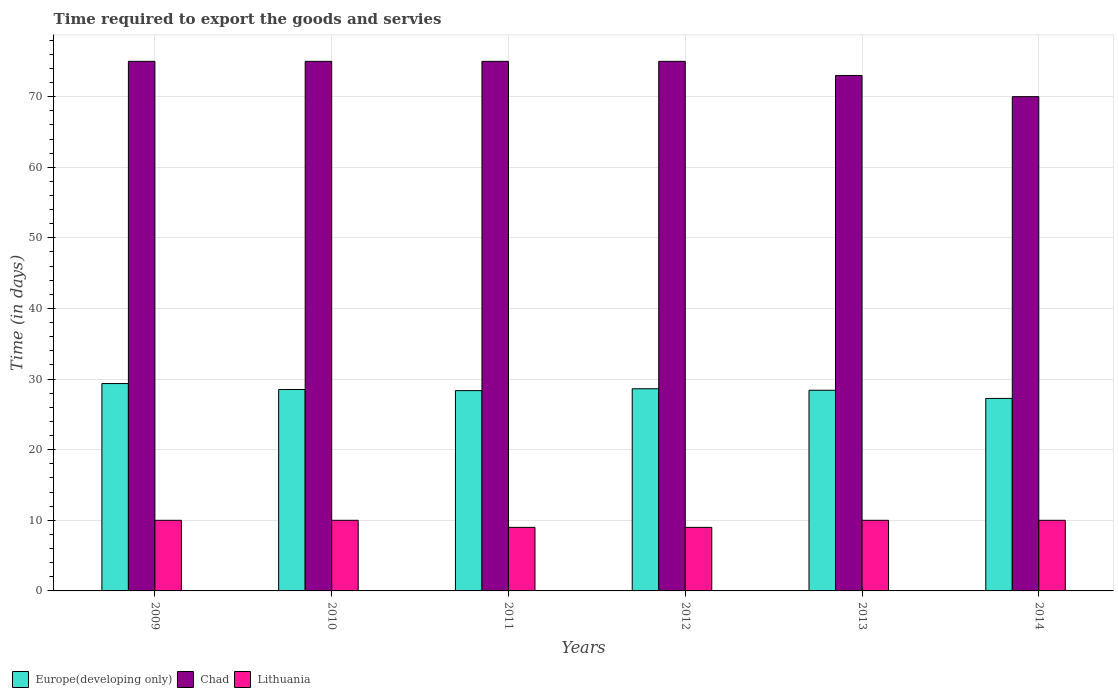How many different coloured bars are there?
Offer a terse response. 3. Are the number of bars per tick equal to the number of legend labels?
Make the answer very short. Yes. How many bars are there on the 6th tick from the left?
Provide a succinct answer. 3. How many bars are there on the 1st tick from the right?
Your answer should be very brief. 3. What is the number of days required to export the goods and services in Europe(developing only) in 2010?
Offer a terse response. 28.53. Across all years, what is the maximum number of days required to export the goods and services in Chad?
Your answer should be very brief. 75. Across all years, what is the minimum number of days required to export the goods and services in Europe(developing only)?
Provide a succinct answer. 27.26. In which year was the number of days required to export the goods and services in Chad minimum?
Make the answer very short. 2014. What is the total number of days required to export the goods and services in Chad in the graph?
Ensure brevity in your answer.  443. What is the difference between the number of days required to export the goods and services in Europe(developing only) in 2011 and that in 2014?
Provide a short and direct response. 1.11. What is the difference between the number of days required to export the goods and services in Chad in 2011 and the number of days required to export the goods and services in Europe(developing only) in 2013?
Provide a short and direct response. 46.58. What is the average number of days required to export the goods and services in Europe(developing only) per year?
Keep it short and to the point. 28.43. In the year 2014, what is the difference between the number of days required to export the goods and services in Europe(developing only) and number of days required to export the goods and services in Chad?
Your answer should be compact. -42.74. What is the ratio of the number of days required to export the goods and services in Chad in 2012 to that in 2014?
Make the answer very short. 1.07. Is the number of days required to export the goods and services in Europe(developing only) in 2010 less than that in 2012?
Keep it short and to the point. Yes. Is the difference between the number of days required to export the goods and services in Europe(developing only) in 2010 and 2011 greater than the difference between the number of days required to export the goods and services in Chad in 2010 and 2011?
Keep it short and to the point. Yes. What is the difference between the highest and the second highest number of days required to export the goods and services in Europe(developing only)?
Provide a short and direct response. 0.74. What is the difference between the highest and the lowest number of days required to export the goods and services in Lithuania?
Ensure brevity in your answer.  1. Is the sum of the number of days required to export the goods and services in Chad in 2009 and 2013 greater than the maximum number of days required to export the goods and services in Lithuania across all years?
Offer a terse response. Yes. What does the 3rd bar from the left in 2009 represents?
Make the answer very short. Lithuania. What does the 1st bar from the right in 2010 represents?
Offer a terse response. Lithuania. What is the difference between two consecutive major ticks on the Y-axis?
Keep it short and to the point. 10. Does the graph contain any zero values?
Your response must be concise. No. How many legend labels are there?
Ensure brevity in your answer.  3. What is the title of the graph?
Offer a very short reply. Time required to export the goods and servies. Does "Central Europe" appear as one of the legend labels in the graph?
Offer a terse response. No. What is the label or title of the X-axis?
Provide a succinct answer. Years. What is the label or title of the Y-axis?
Your response must be concise. Time (in days). What is the Time (in days) of Europe(developing only) in 2009?
Give a very brief answer. 29.37. What is the Time (in days) of Europe(developing only) in 2010?
Offer a terse response. 28.53. What is the Time (in days) of Chad in 2010?
Offer a terse response. 75. What is the Time (in days) in Lithuania in 2010?
Give a very brief answer. 10. What is the Time (in days) of Europe(developing only) in 2011?
Provide a short and direct response. 28.37. What is the Time (in days) of Europe(developing only) in 2012?
Ensure brevity in your answer.  28.63. What is the Time (in days) of Europe(developing only) in 2013?
Your answer should be very brief. 28.42. What is the Time (in days) in Chad in 2013?
Your answer should be very brief. 73. What is the Time (in days) in Europe(developing only) in 2014?
Offer a very short reply. 27.26. Across all years, what is the maximum Time (in days) of Europe(developing only)?
Your answer should be compact. 29.37. Across all years, what is the maximum Time (in days) of Chad?
Make the answer very short. 75. Across all years, what is the minimum Time (in days) in Europe(developing only)?
Offer a very short reply. 27.26. Across all years, what is the minimum Time (in days) in Lithuania?
Give a very brief answer. 9. What is the total Time (in days) of Europe(developing only) in the graph?
Your answer should be compact. 170.58. What is the total Time (in days) in Chad in the graph?
Make the answer very short. 443. What is the total Time (in days) of Lithuania in the graph?
Offer a very short reply. 58. What is the difference between the Time (in days) of Europe(developing only) in 2009 and that in 2010?
Offer a terse response. 0.84. What is the difference between the Time (in days) in Europe(developing only) in 2009 and that in 2011?
Make the answer very short. 1. What is the difference between the Time (in days) of Lithuania in 2009 and that in 2011?
Your answer should be very brief. 1. What is the difference between the Time (in days) of Europe(developing only) in 2009 and that in 2012?
Your answer should be compact. 0.74. What is the difference between the Time (in days) of Chad in 2009 and that in 2013?
Offer a terse response. 2. What is the difference between the Time (in days) of Lithuania in 2009 and that in 2013?
Your response must be concise. 0. What is the difference between the Time (in days) of Europe(developing only) in 2009 and that in 2014?
Ensure brevity in your answer.  2.11. What is the difference between the Time (in days) in Chad in 2009 and that in 2014?
Provide a succinct answer. 5. What is the difference between the Time (in days) in Europe(developing only) in 2010 and that in 2011?
Offer a very short reply. 0.16. What is the difference between the Time (in days) of Chad in 2010 and that in 2011?
Offer a very short reply. 0. What is the difference between the Time (in days) in Europe(developing only) in 2010 and that in 2012?
Offer a terse response. -0.11. What is the difference between the Time (in days) of Europe(developing only) in 2010 and that in 2013?
Offer a terse response. 0.11. What is the difference between the Time (in days) of Chad in 2010 and that in 2013?
Offer a terse response. 2. What is the difference between the Time (in days) of Lithuania in 2010 and that in 2013?
Your response must be concise. 0. What is the difference between the Time (in days) in Europe(developing only) in 2010 and that in 2014?
Offer a very short reply. 1.26. What is the difference between the Time (in days) in Chad in 2010 and that in 2014?
Give a very brief answer. 5. What is the difference between the Time (in days) of Europe(developing only) in 2011 and that in 2012?
Provide a short and direct response. -0.26. What is the difference between the Time (in days) of Europe(developing only) in 2011 and that in 2013?
Your answer should be compact. -0.05. What is the difference between the Time (in days) of Lithuania in 2011 and that in 2013?
Your response must be concise. -1. What is the difference between the Time (in days) in Europe(developing only) in 2011 and that in 2014?
Keep it short and to the point. 1.11. What is the difference between the Time (in days) in Europe(developing only) in 2012 and that in 2013?
Your response must be concise. 0.21. What is the difference between the Time (in days) of Chad in 2012 and that in 2013?
Make the answer very short. 2. What is the difference between the Time (in days) of Europe(developing only) in 2012 and that in 2014?
Make the answer very short. 1.37. What is the difference between the Time (in days) of Chad in 2012 and that in 2014?
Your answer should be very brief. 5. What is the difference between the Time (in days) of Lithuania in 2012 and that in 2014?
Provide a succinct answer. -1. What is the difference between the Time (in days) in Europe(developing only) in 2013 and that in 2014?
Provide a short and direct response. 1.16. What is the difference between the Time (in days) in Lithuania in 2013 and that in 2014?
Your answer should be very brief. 0. What is the difference between the Time (in days) of Europe(developing only) in 2009 and the Time (in days) of Chad in 2010?
Your answer should be very brief. -45.63. What is the difference between the Time (in days) in Europe(developing only) in 2009 and the Time (in days) in Lithuania in 2010?
Provide a short and direct response. 19.37. What is the difference between the Time (in days) in Europe(developing only) in 2009 and the Time (in days) in Chad in 2011?
Ensure brevity in your answer.  -45.63. What is the difference between the Time (in days) in Europe(developing only) in 2009 and the Time (in days) in Lithuania in 2011?
Your answer should be compact. 20.37. What is the difference between the Time (in days) of Chad in 2009 and the Time (in days) of Lithuania in 2011?
Offer a very short reply. 66. What is the difference between the Time (in days) of Europe(developing only) in 2009 and the Time (in days) of Chad in 2012?
Provide a succinct answer. -45.63. What is the difference between the Time (in days) in Europe(developing only) in 2009 and the Time (in days) in Lithuania in 2012?
Your answer should be very brief. 20.37. What is the difference between the Time (in days) of Chad in 2009 and the Time (in days) of Lithuania in 2012?
Give a very brief answer. 66. What is the difference between the Time (in days) in Europe(developing only) in 2009 and the Time (in days) in Chad in 2013?
Offer a terse response. -43.63. What is the difference between the Time (in days) of Europe(developing only) in 2009 and the Time (in days) of Lithuania in 2013?
Your answer should be compact. 19.37. What is the difference between the Time (in days) in Europe(developing only) in 2009 and the Time (in days) in Chad in 2014?
Offer a terse response. -40.63. What is the difference between the Time (in days) of Europe(developing only) in 2009 and the Time (in days) of Lithuania in 2014?
Provide a short and direct response. 19.37. What is the difference between the Time (in days) of Chad in 2009 and the Time (in days) of Lithuania in 2014?
Provide a succinct answer. 65. What is the difference between the Time (in days) of Europe(developing only) in 2010 and the Time (in days) of Chad in 2011?
Offer a terse response. -46.47. What is the difference between the Time (in days) in Europe(developing only) in 2010 and the Time (in days) in Lithuania in 2011?
Make the answer very short. 19.53. What is the difference between the Time (in days) of Chad in 2010 and the Time (in days) of Lithuania in 2011?
Give a very brief answer. 66. What is the difference between the Time (in days) in Europe(developing only) in 2010 and the Time (in days) in Chad in 2012?
Ensure brevity in your answer.  -46.47. What is the difference between the Time (in days) of Europe(developing only) in 2010 and the Time (in days) of Lithuania in 2012?
Offer a very short reply. 19.53. What is the difference between the Time (in days) in Chad in 2010 and the Time (in days) in Lithuania in 2012?
Keep it short and to the point. 66. What is the difference between the Time (in days) of Europe(developing only) in 2010 and the Time (in days) of Chad in 2013?
Provide a short and direct response. -44.47. What is the difference between the Time (in days) in Europe(developing only) in 2010 and the Time (in days) in Lithuania in 2013?
Your response must be concise. 18.53. What is the difference between the Time (in days) in Europe(developing only) in 2010 and the Time (in days) in Chad in 2014?
Your answer should be compact. -41.47. What is the difference between the Time (in days) in Europe(developing only) in 2010 and the Time (in days) in Lithuania in 2014?
Ensure brevity in your answer.  18.53. What is the difference between the Time (in days) of Chad in 2010 and the Time (in days) of Lithuania in 2014?
Provide a short and direct response. 65. What is the difference between the Time (in days) in Europe(developing only) in 2011 and the Time (in days) in Chad in 2012?
Keep it short and to the point. -46.63. What is the difference between the Time (in days) in Europe(developing only) in 2011 and the Time (in days) in Lithuania in 2012?
Provide a short and direct response. 19.37. What is the difference between the Time (in days) of Europe(developing only) in 2011 and the Time (in days) of Chad in 2013?
Make the answer very short. -44.63. What is the difference between the Time (in days) of Europe(developing only) in 2011 and the Time (in days) of Lithuania in 2013?
Keep it short and to the point. 18.37. What is the difference between the Time (in days) of Europe(developing only) in 2011 and the Time (in days) of Chad in 2014?
Make the answer very short. -41.63. What is the difference between the Time (in days) in Europe(developing only) in 2011 and the Time (in days) in Lithuania in 2014?
Offer a terse response. 18.37. What is the difference between the Time (in days) of Chad in 2011 and the Time (in days) of Lithuania in 2014?
Your answer should be compact. 65. What is the difference between the Time (in days) in Europe(developing only) in 2012 and the Time (in days) in Chad in 2013?
Your answer should be very brief. -44.37. What is the difference between the Time (in days) in Europe(developing only) in 2012 and the Time (in days) in Lithuania in 2013?
Offer a very short reply. 18.63. What is the difference between the Time (in days) in Europe(developing only) in 2012 and the Time (in days) in Chad in 2014?
Give a very brief answer. -41.37. What is the difference between the Time (in days) in Europe(developing only) in 2012 and the Time (in days) in Lithuania in 2014?
Your response must be concise. 18.63. What is the difference between the Time (in days) in Europe(developing only) in 2013 and the Time (in days) in Chad in 2014?
Provide a succinct answer. -41.58. What is the difference between the Time (in days) of Europe(developing only) in 2013 and the Time (in days) of Lithuania in 2014?
Your answer should be compact. 18.42. What is the average Time (in days) in Europe(developing only) per year?
Ensure brevity in your answer.  28.43. What is the average Time (in days) in Chad per year?
Make the answer very short. 73.83. What is the average Time (in days) in Lithuania per year?
Your response must be concise. 9.67. In the year 2009, what is the difference between the Time (in days) of Europe(developing only) and Time (in days) of Chad?
Ensure brevity in your answer.  -45.63. In the year 2009, what is the difference between the Time (in days) in Europe(developing only) and Time (in days) in Lithuania?
Ensure brevity in your answer.  19.37. In the year 2009, what is the difference between the Time (in days) in Chad and Time (in days) in Lithuania?
Ensure brevity in your answer.  65. In the year 2010, what is the difference between the Time (in days) of Europe(developing only) and Time (in days) of Chad?
Offer a terse response. -46.47. In the year 2010, what is the difference between the Time (in days) of Europe(developing only) and Time (in days) of Lithuania?
Provide a succinct answer. 18.53. In the year 2011, what is the difference between the Time (in days) of Europe(developing only) and Time (in days) of Chad?
Your response must be concise. -46.63. In the year 2011, what is the difference between the Time (in days) of Europe(developing only) and Time (in days) of Lithuania?
Make the answer very short. 19.37. In the year 2011, what is the difference between the Time (in days) of Chad and Time (in days) of Lithuania?
Make the answer very short. 66. In the year 2012, what is the difference between the Time (in days) in Europe(developing only) and Time (in days) in Chad?
Offer a terse response. -46.37. In the year 2012, what is the difference between the Time (in days) in Europe(developing only) and Time (in days) in Lithuania?
Your answer should be compact. 19.63. In the year 2013, what is the difference between the Time (in days) in Europe(developing only) and Time (in days) in Chad?
Keep it short and to the point. -44.58. In the year 2013, what is the difference between the Time (in days) in Europe(developing only) and Time (in days) in Lithuania?
Provide a short and direct response. 18.42. In the year 2013, what is the difference between the Time (in days) in Chad and Time (in days) in Lithuania?
Keep it short and to the point. 63. In the year 2014, what is the difference between the Time (in days) in Europe(developing only) and Time (in days) in Chad?
Make the answer very short. -42.74. In the year 2014, what is the difference between the Time (in days) of Europe(developing only) and Time (in days) of Lithuania?
Provide a short and direct response. 17.26. In the year 2014, what is the difference between the Time (in days) in Chad and Time (in days) in Lithuania?
Your answer should be compact. 60. What is the ratio of the Time (in days) in Europe(developing only) in 2009 to that in 2010?
Offer a very short reply. 1.03. What is the ratio of the Time (in days) of Chad in 2009 to that in 2010?
Keep it short and to the point. 1. What is the ratio of the Time (in days) in Lithuania in 2009 to that in 2010?
Provide a succinct answer. 1. What is the ratio of the Time (in days) of Europe(developing only) in 2009 to that in 2011?
Your answer should be very brief. 1.04. What is the ratio of the Time (in days) of Europe(developing only) in 2009 to that in 2012?
Provide a succinct answer. 1.03. What is the ratio of the Time (in days) in Chad in 2009 to that in 2012?
Provide a succinct answer. 1. What is the ratio of the Time (in days) in Lithuania in 2009 to that in 2012?
Offer a terse response. 1.11. What is the ratio of the Time (in days) of Europe(developing only) in 2009 to that in 2013?
Keep it short and to the point. 1.03. What is the ratio of the Time (in days) of Chad in 2009 to that in 2013?
Ensure brevity in your answer.  1.03. What is the ratio of the Time (in days) in Europe(developing only) in 2009 to that in 2014?
Offer a terse response. 1.08. What is the ratio of the Time (in days) of Chad in 2009 to that in 2014?
Your response must be concise. 1.07. What is the ratio of the Time (in days) in Lithuania in 2009 to that in 2014?
Keep it short and to the point. 1. What is the ratio of the Time (in days) in Europe(developing only) in 2010 to that in 2011?
Provide a succinct answer. 1.01. What is the ratio of the Time (in days) in Chad in 2010 to that in 2011?
Your response must be concise. 1. What is the ratio of the Time (in days) in Lithuania in 2010 to that in 2011?
Your response must be concise. 1.11. What is the ratio of the Time (in days) in Lithuania in 2010 to that in 2012?
Ensure brevity in your answer.  1.11. What is the ratio of the Time (in days) of Europe(developing only) in 2010 to that in 2013?
Provide a short and direct response. 1. What is the ratio of the Time (in days) of Chad in 2010 to that in 2013?
Make the answer very short. 1.03. What is the ratio of the Time (in days) in Europe(developing only) in 2010 to that in 2014?
Keep it short and to the point. 1.05. What is the ratio of the Time (in days) of Chad in 2010 to that in 2014?
Ensure brevity in your answer.  1.07. What is the ratio of the Time (in days) of Europe(developing only) in 2011 to that in 2013?
Your answer should be very brief. 1. What is the ratio of the Time (in days) in Chad in 2011 to that in 2013?
Your response must be concise. 1.03. What is the ratio of the Time (in days) in Europe(developing only) in 2011 to that in 2014?
Ensure brevity in your answer.  1.04. What is the ratio of the Time (in days) of Chad in 2011 to that in 2014?
Provide a succinct answer. 1.07. What is the ratio of the Time (in days) in Europe(developing only) in 2012 to that in 2013?
Ensure brevity in your answer.  1.01. What is the ratio of the Time (in days) in Chad in 2012 to that in 2013?
Your answer should be compact. 1.03. What is the ratio of the Time (in days) in Europe(developing only) in 2012 to that in 2014?
Make the answer very short. 1.05. What is the ratio of the Time (in days) in Chad in 2012 to that in 2014?
Provide a short and direct response. 1.07. What is the ratio of the Time (in days) in Europe(developing only) in 2013 to that in 2014?
Your answer should be compact. 1.04. What is the ratio of the Time (in days) in Chad in 2013 to that in 2014?
Your answer should be compact. 1.04. What is the difference between the highest and the second highest Time (in days) of Europe(developing only)?
Ensure brevity in your answer.  0.74. What is the difference between the highest and the lowest Time (in days) in Europe(developing only)?
Offer a terse response. 2.11. What is the difference between the highest and the lowest Time (in days) in Lithuania?
Ensure brevity in your answer.  1. 